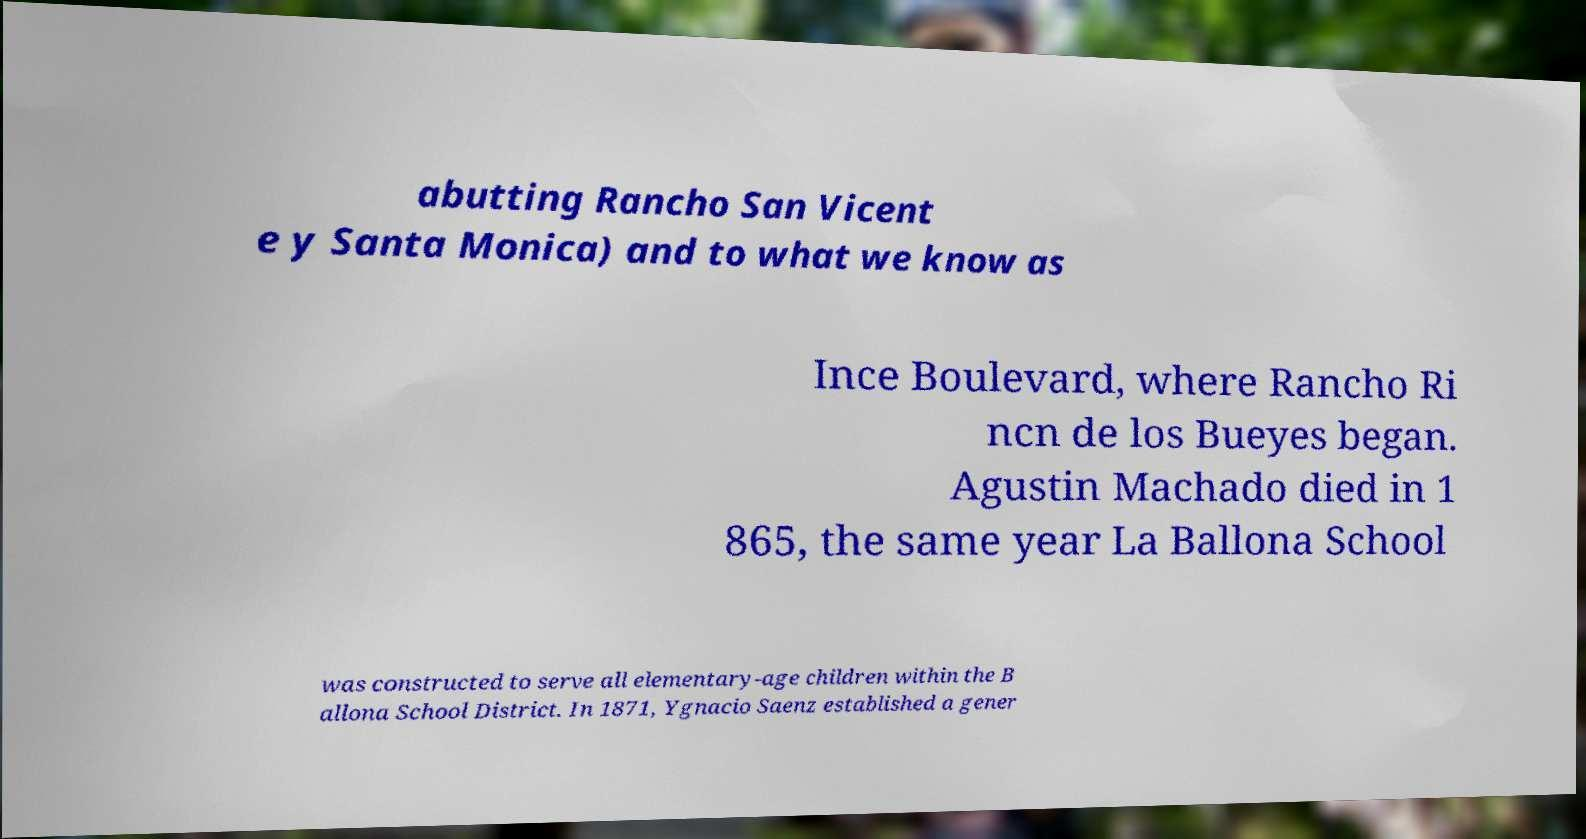I need the written content from this picture converted into text. Can you do that? abutting Rancho San Vicent e y Santa Monica) and to what we know as Ince Boulevard, where Rancho Ri ncn de los Bueyes began. Agustin Machado died in 1 865, the same year La Ballona School was constructed to serve all elementary-age children within the B allona School District. In 1871, Ygnacio Saenz established a gener 